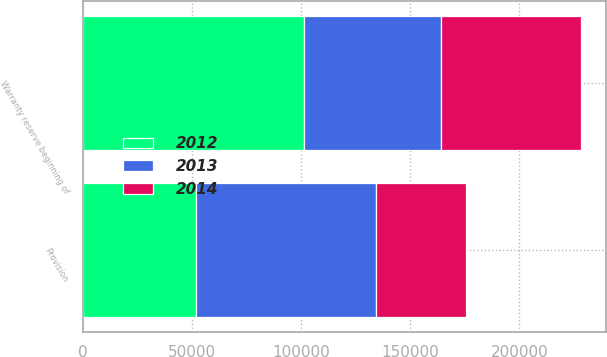<chart> <loc_0><loc_0><loc_500><loc_500><stacked_bar_chart><ecel><fcel>Warranty reserve beginning of<fcel>Provision<nl><fcel>2012<fcel>101507<fcel>51668<nl><fcel>2013<fcel>62742<fcel>82860<nl><fcel>2014<fcel>64008<fcel>41138<nl></chart> 